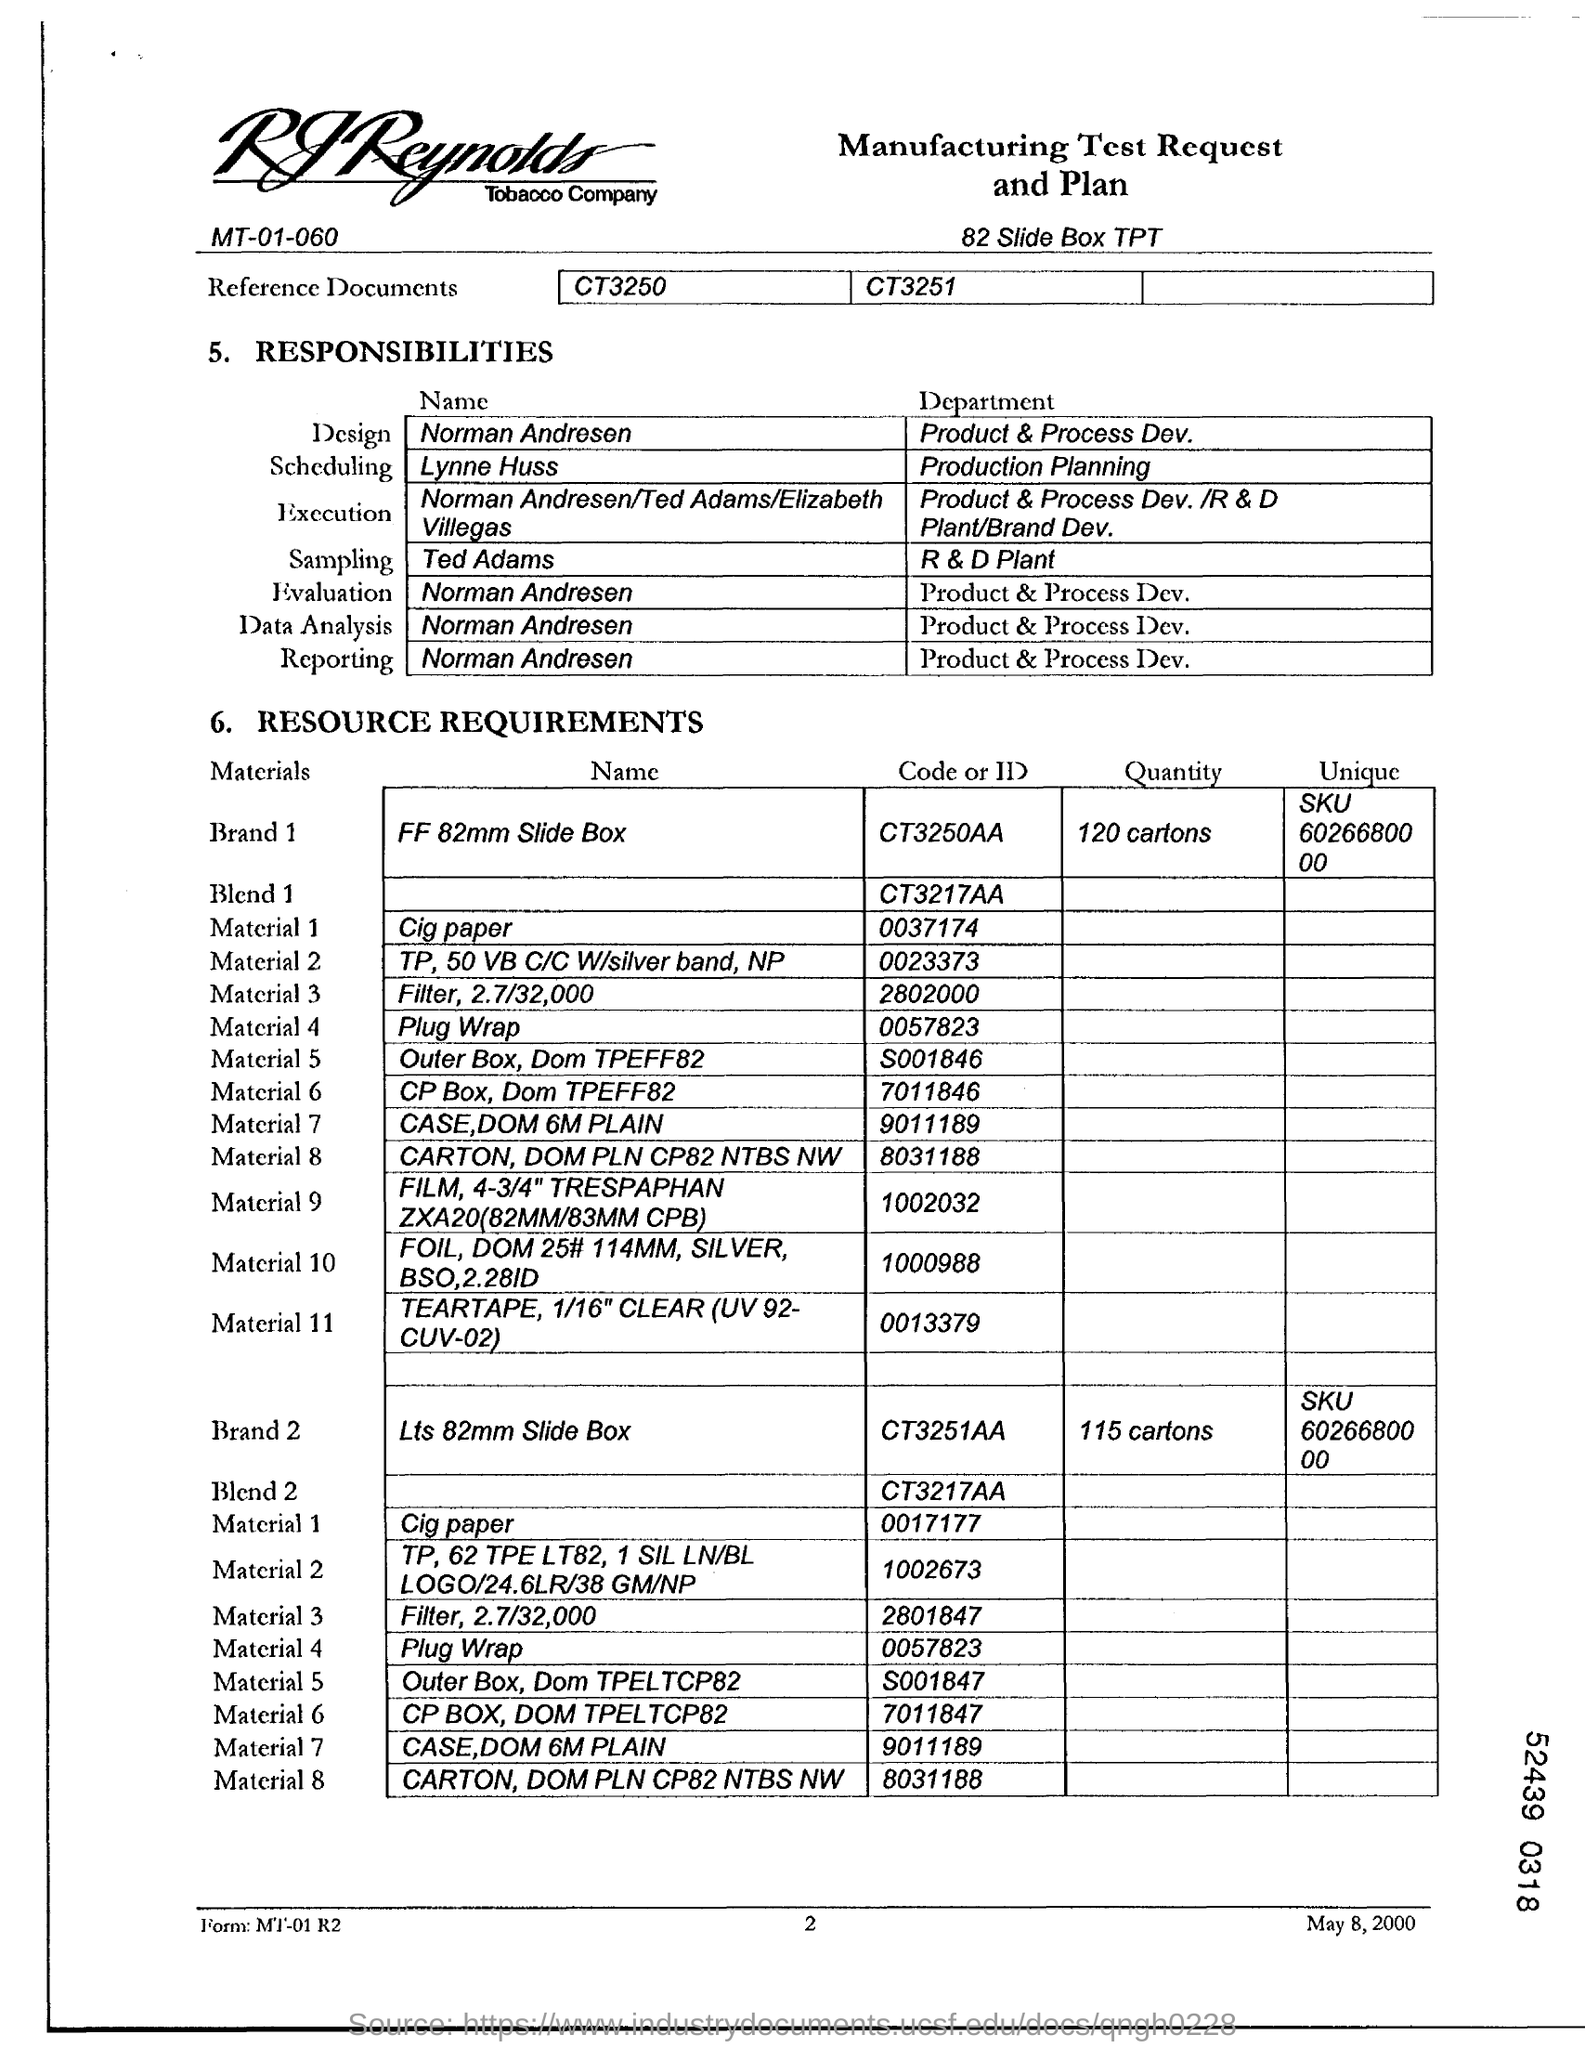In which department Ted Adams works?
Your answer should be compact. R & D Plant. In which department Norman Andresen works?
Ensure brevity in your answer.  Product & Process Dev. Which "department" is "Ted Adams"?
Your response must be concise. R & D Plant. What is the date on the document?
Make the answer very short. May 8, 2000. 